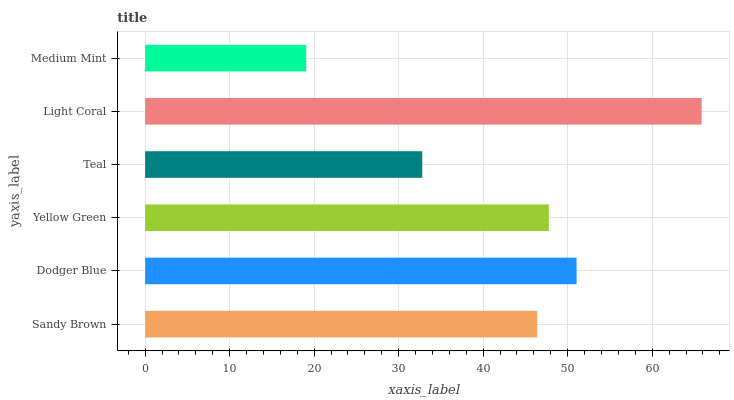Is Medium Mint the minimum?
Answer yes or no. Yes. Is Light Coral the maximum?
Answer yes or no. Yes. Is Dodger Blue the minimum?
Answer yes or no. No. Is Dodger Blue the maximum?
Answer yes or no. No. Is Dodger Blue greater than Sandy Brown?
Answer yes or no. Yes. Is Sandy Brown less than Dodger Blue?
Answer yes or no. Yes. Is Sandy Brown greater than Dodger Blue?
Answer yes or no. No. Is Dodger Blue less than Sandy Brown?
Answer yes or no. No. Is Yellow Green the high median?
Answer yes or no. Yes. Is Sandy Brown the low median?
Answer yes or no. Yes. Is Medium Mint the high median?
Answer yes or no. No. Is Dodger Blue the low median?
Answer yes or no. No. 